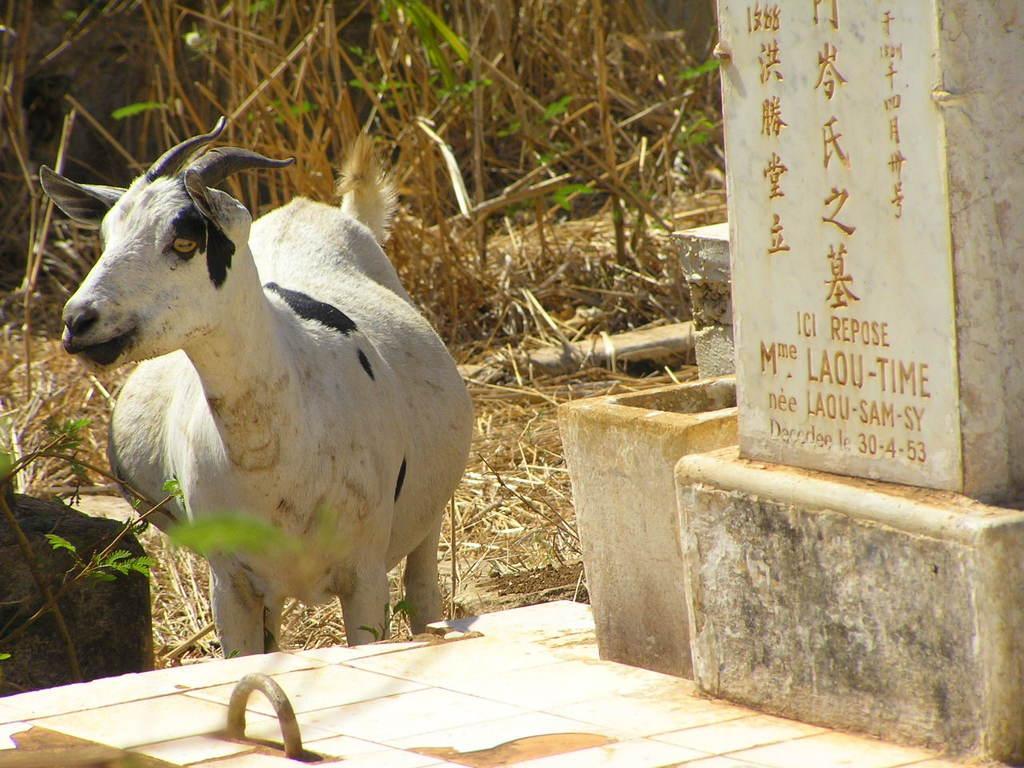How would you summarize this image in a sentence or two? This is a goat standing. This looks like a stone with the letters carved on it. I can see the dried grass. 